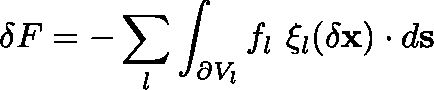<formula> <loc_0><loc_0><loc_500><loc_500>\delta F = - \sum _ { l } \int _ { \partial V _ { l } } f _ { l } \ \xi _ { l } ( \delta x ) \cdot d s</formula> 